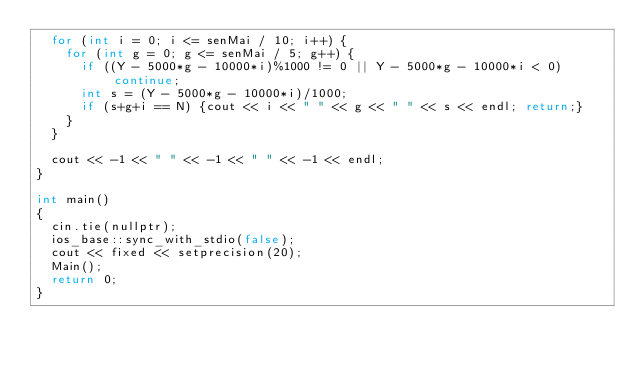<code> <loc_0><loc_0><loc_500><loc_500><_C++_>  for (int i = 0; i <= senMai / 10; i++) {
    for (int g = 0; g <= senMai / 5; g++) {
      if ((Y - 5000*g - 10000*i)%1000 != 0 || Y - 5000*g - 10000*i < 0) continue;
      int s = (Y - 5000*g - 10000*i)/1000;
      if (s+g+i == N) {cout << i << " " << g << " " << s << endl; return;}
    }
  }
  
  cout << -1 << " " << -1 << " " << -1 << endl;
}

int main()
{
  cin.tie(nullptr);
  ios_base::sync_with_stdio(false);
  cout << fixed << setprecision(20);
  Main();
  return 0;
}
</code> 